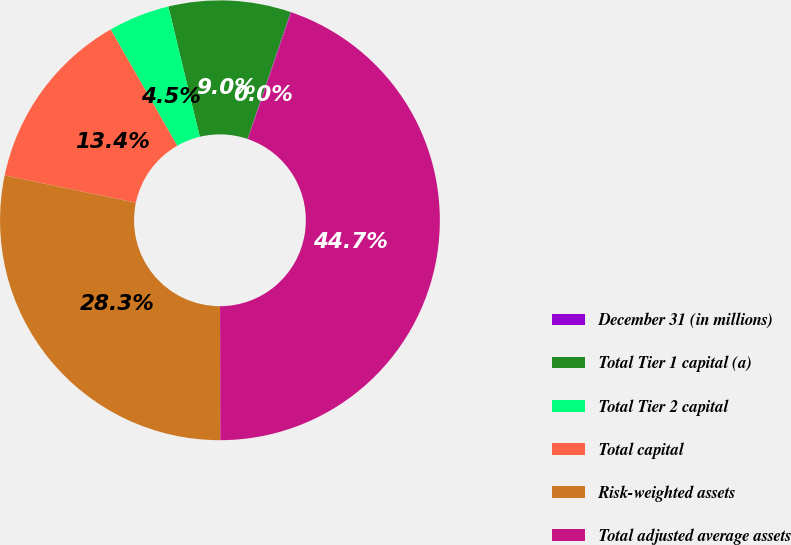Convert chart. <chart><loc_0><loc_0><loc_500><loc_500><pie_chart><fcel>December 31 (in millions)<fcel>Total Tier 1 capital (a)<fcel>Total Tier 2 capital<fcel>Total capital<fcel>Risk-weighted assets<fcel>Total adjusted average assets<nl><fcel>0.05%<fcel>8.98%<fcel>4.51%<fcel>13.45%<fcel>28.3%<fcel>44.72%<nl></chart> 